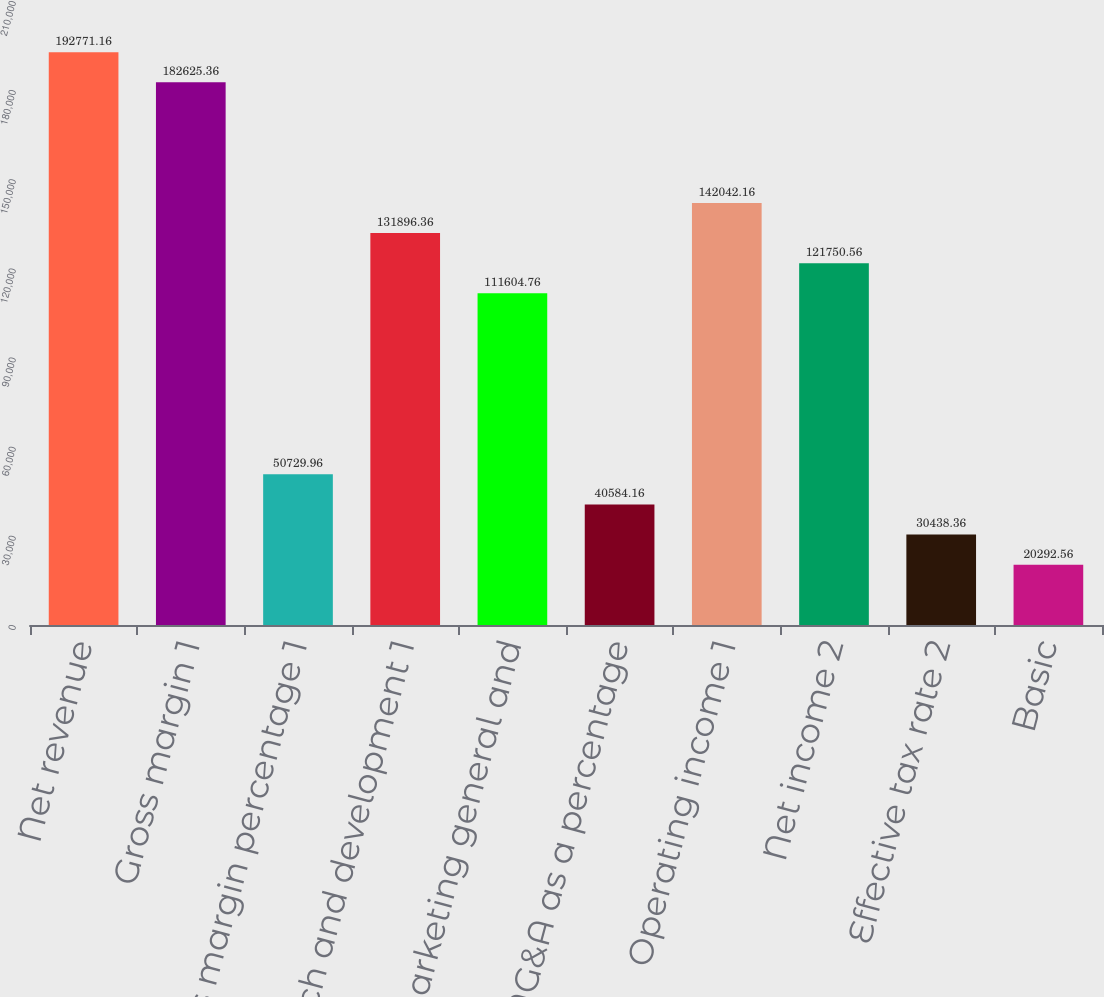Convert chart. <chart><loc_0><loc_0><loc_500><loc_500><bar_chart><fcel>Net revenue<fcel>Gross margin 1<fcel>Gross margin percentage 1<fcel>Research and development 1<fcel>Marketing general and<fcel>R&D and MG&A as a percentage<fcel>Operating income 1<fcel>Net income 2<fcel>Effective tax rate 2<fcel>Basic<nl><fcel>192771<fcel>182625<fcel>50730<fcel>131896<fcel>111605<fcel>40584.2<fcel>142042<fcel>121751<fcel>30438.4<fcel>20292.6<nl></chart> 